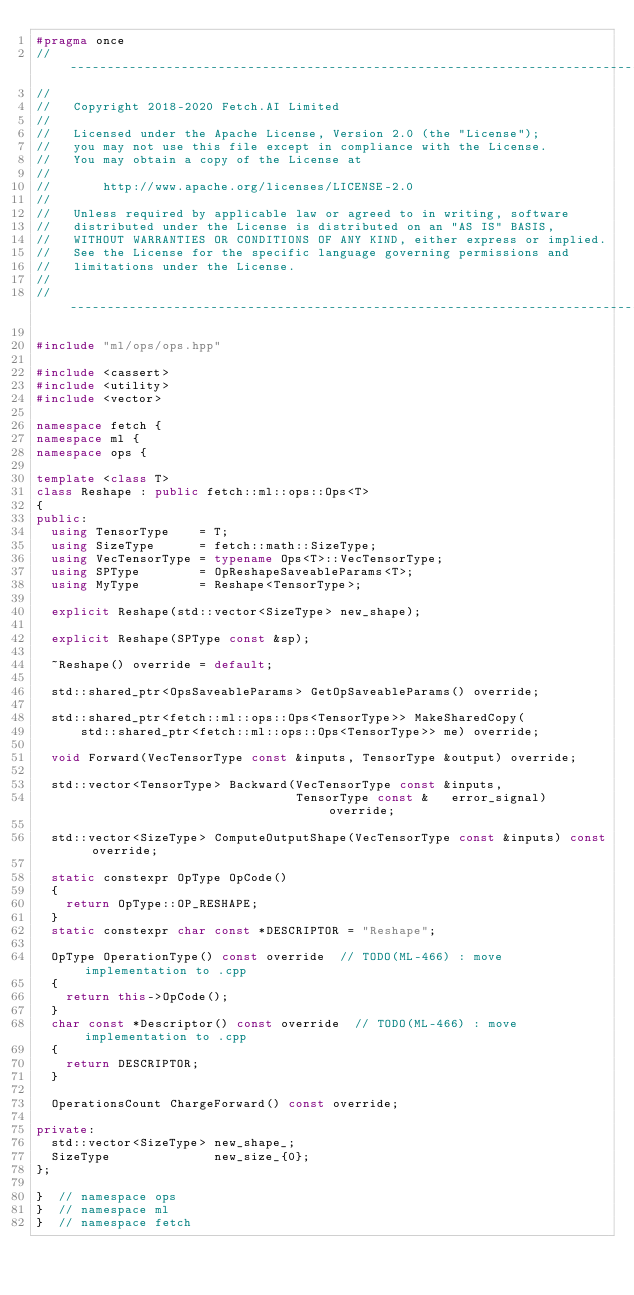<code> <loc_0><loc_0><loc_500><loc_500><_C++_>#pragma once
//------------------------------------------------------------------------------
//
//   Copyright 2018-2020 Fetch.AI Limited
//
//   Licensed under the Apache License, Version 2.0 (the "License");
//   you may not use this file except in compliance with the License.
//   You may obtain a copy of the License at
//
//       http://www.apache.org/licenses/LICENSE-2.0
//
//   Unless required by applicable law or agreed to in writing, software
//   distributed under the License is distributed on an "AS IS" BASIS,
//   WITHOUT WARRANTIES OR CONDITIONS OF ANY KIND, either express or implied.
//   See the License for the specific language governing permissions and
//   limitations under the License.
//
//------------------------------------------------------------------------------

#include "ml/ops/ops.hpp"

#include <cassert>
#include <utility>
#include <vector>

namespace fetch {
namespace ml {
namespace ops {

template <class T>
class Reshape : public fetch::ml::ops::Ops<T>
{
public:
  using TensorType    = T;
  using SizeType      = fetch::math::SizeType;
  using VecTensorType = typename Ops<T>::VecTensorType;
  using SPType        = OpReshapeSaveableParams<T>;
  using MyType        = Reshape<TensorType>;

  explicit Reshape(std::vector<SizeType> new_shape);

  explicit Reshape(SPType const &sp);

  ~Reshape() override = default;

  std::shared_ptr<OpsSaveableParams> GetOpSaveableParams() override;

  std::shared_ptr<fetch::ml::ops::Ops<TensorType>> MakeSharedCopy(
      std::shared_ptr<fetch::ml::ops::Ops<TensorType>> me) override;

  void Forward(VecTensorType const &inputs, TensorType &output) override;

  std::vector<TensorType> Backward(VecTensorType const &inputs,
                                   TensorType const &   error_signal) override;

  std::vector<SizeType> ComputeOutputShape(VecTensorType const &inputs) const override;

  static constexpr OpType OpCode()
  {
    return OpType::OP_RESHAPE;
  }
  static constexpr char const *DESCRIPTOR = "Reshape";

  OpType OperationType() const override  // TODO(ML-466) : move implementation to .cpp
  {
    return this->OpCode();
  }
  char const *Descriptor() const override  // TODO(ML-466) : move implementation to .cpp
  {
    return DESCRIPTOR;
  }

  OperationsCount ChargeForward() const override;

private:
  std::vector<SizeType> new_shape_;
  SizeType              new_size_{0};
};

}  // namespace ops
}  // namespace ml
}  // namespace fetch
</code> 